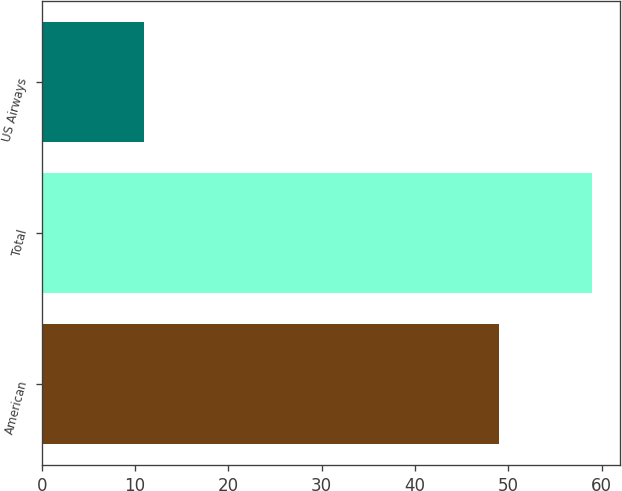Convert chart. <chart><loc_0><loc_0><loc_500><loc_500><bar_chart><fcel>American<fcel>Total<fcel>US Airways<nl><fcel>49<fcel>59<fcel>11<nl></chart> 